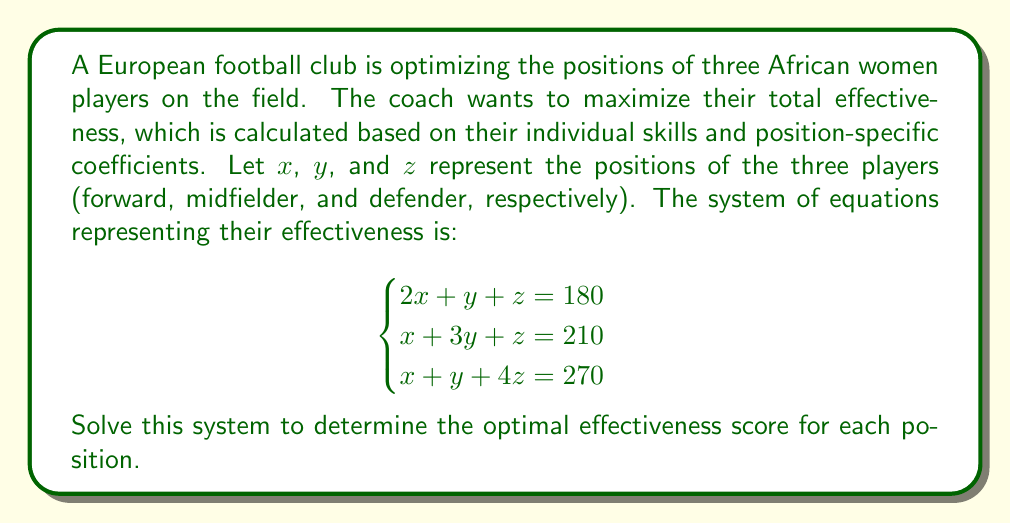Can you solve this math problem? Let's solve this system of equations using the elimination method:

Step 1: Multiply the first equation by -1 and add it to the second equation to eliminate x:
$$\begin{aligned}
-1(2x + y + z = 180) &\implies -2x - y - z = -180 \\
x + 3y + z = 210 &\implies x + 3y + z = 210 \\
\hline
2y = 30
\end{aligned}$$

Step 2: Solve for y:
$$y = 15$$

Step 3: Substitute y = 15 into the first equation:
$$\begin{aligned}
2x + 15 + z &= 180 \\
2x + z &= 165
\end{aligned}$$

Step 4: Multiply the first equation by -2 and add it to the third equation to eliminate x:
$$\begin{aligned}
-2(2x + y + z = 180) &\implies -4x - 2y - 2z = -360 \\
x + y + 4z = 270 &\implies x + y + 4z = 270 \\
\hline
-y + 2z = -90
\end{aligned}$$

Step 5: Substitute y = 15 into the equation from Step 4:
$$\begin{aligned}
-15 + 2z &= -90 \\
2z &= -75 \\
z &= -37.5
\end{aligned}$$

Step 6: Substitute y = 15 and z = -37.5 into the first equation to solve for x:
$$\begin{aligned}
2x + 15 + (-37.5) &= 180 \\
2x &= 202.5 \\
x &= 101.25
\end{aligned}$$

Therefore, the optimal effectiveness scores are:
x (forward) = 101.25
y (midfielder) = 15
z (defender) = -37.5
Answer: $x = 101.25$, $y = 15$, $z = -37.5$ 